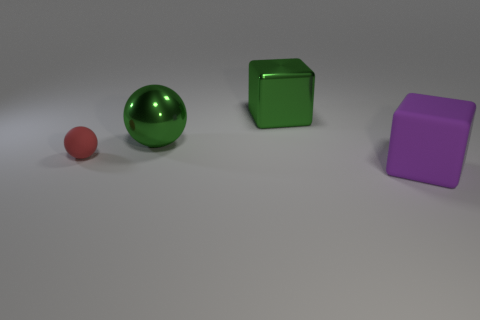Add 4 small green metallic blocks. How many objects exist? 8 Subtract 0 cyan cylinders. How many objects are left? 4 Subtract all blue cubes. Subtract all brown cylinders. How many cubes are left? 2 Subtract all blue blocks. How many green balls are left? 1 Subtract all big purple matte cubes. Subtract all large gray rubber cylinders. How many objects are left? 3 Add 2 big matte things. How many big matte things are left? 3 Add 3 green cubes. How many green cubes exist? 4 